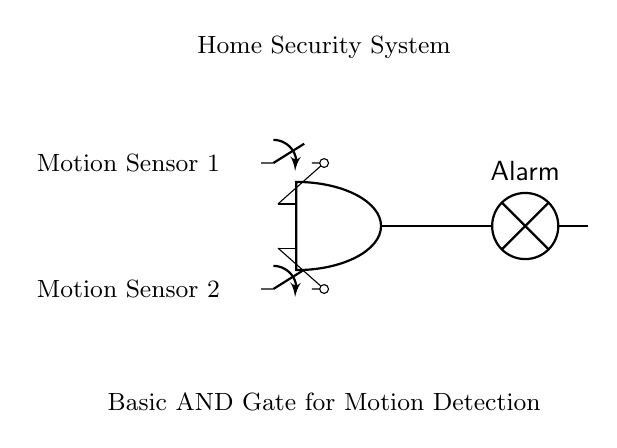What type of gate is depicted in the circuit? The diagram shows an AND gate, which is identified by the shape and label of the component.
Answer: AND gate How many motion sensors are integrated into this circuit? The circuit includes two motion sensors, as indicated by the two switch components connected to the AND gate inputs.
Answer: Two What is the output device connected to the AND gate? The output of the AND gate is connected to a lamp, denoted by the label "Alarm" in the circuit.
Answer: Alarm What is required for the alarm to activate? The alarm activates only when both motion sensors are triggered, which is characteristic of an AND gate's operation.
Answer: Both sensors What does the label "Home Security System" represent? This label indicates that the entire circuit functions as a home security system, utilizing the motion sensors and the alarm mechanism for security.
Answer: Home Security System What would happen if one motion sensor is triggered while the other is not? If only one motion sensor is triggered, the AND gate will not produce an output, meaning the alarm remains inactive.
Answer: Alarm remains inactive What is the purpose of using an AND gate in this circuit? An AND gate is used to ensure that the alarm is activated only when both sensors detect motion, enhancing security by reducing false alarms.
Answer: Enhance security 